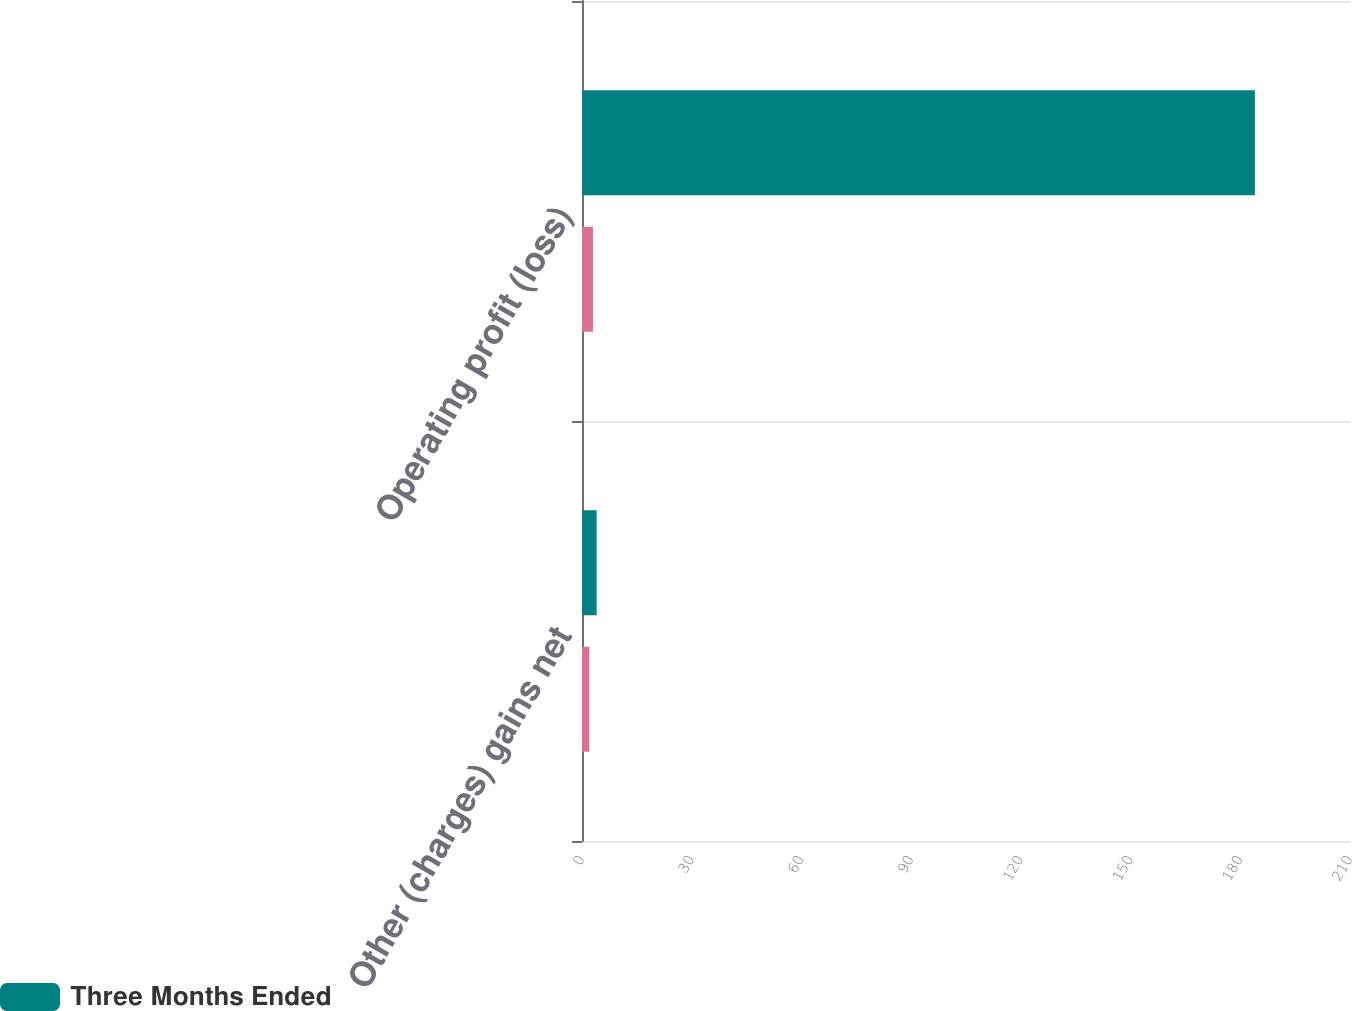Convert chart to OTSL. <chart><loc_0><loc_0><loc_500><loc_500><stacked_bar_chart><ecel><fcel>Other (charges) gains net<fcel>Operating profit (loss)<nl><fcel>Three Months Ended<fcel>4<fcel>184<nl><fcel>nan<fcel>2<fcel>3<nl></chart> 